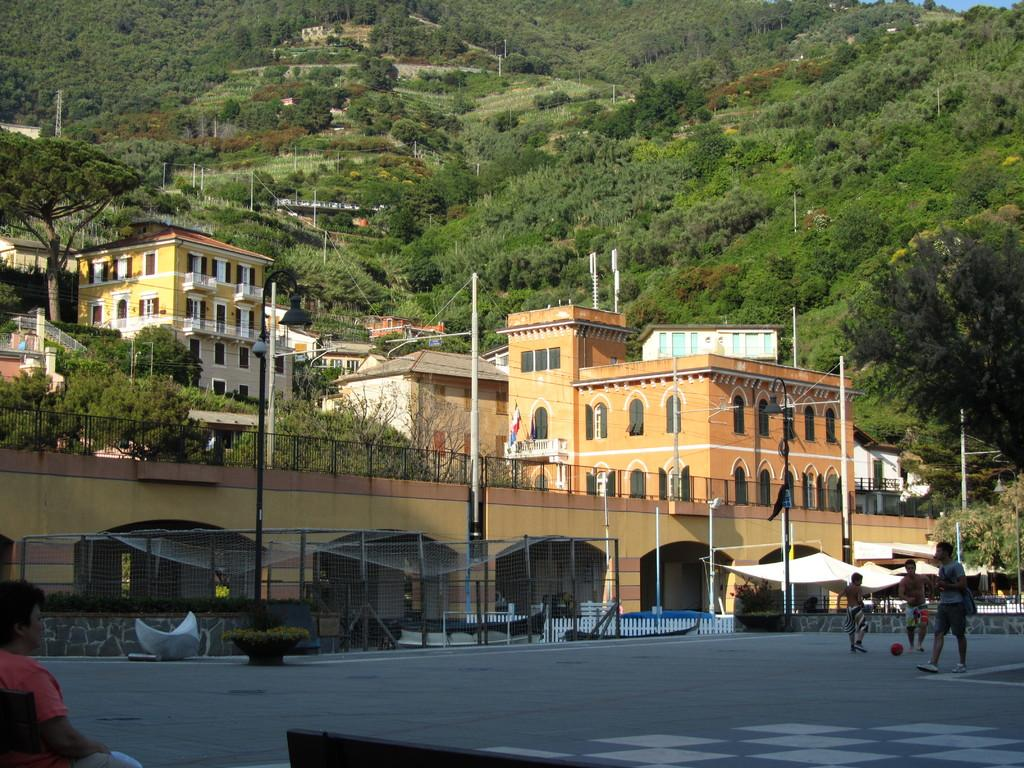How many people are on the road in the image? There are three persons on the road in the image. What object can be seen in addition to the people on the road? There is a ball in the image. What type of structures are visible in the image? There are buildings in the image. What other objects can be seen in the image? There are poles, plants, a fence, and trees in the image. Is there any seating visible in the image? Yes, there is a person sitting on a bench in the image. What type of prison can be seen in the image? There is no prison present in the image. How much payment is required to enter the area shown in the image? There is no mention of payment or any entrance fee in the image. 